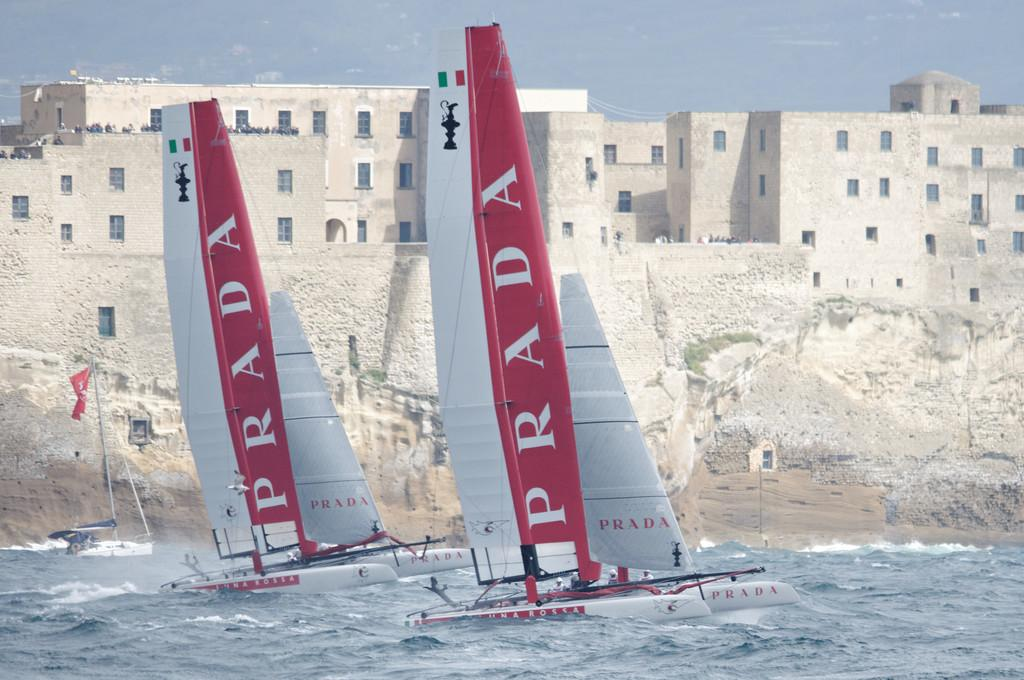What is in the water in the image? There are boats in the water in the image. What can be seen in the background of the image? There are buildings visible in the image. What are the people doing on the buildings? The people are standing on the buildings. How would you describe the sky in the image? The sky is cloudy in the image. What type of tin can be seen in the image? There is no tin present in the image. How many needles are visible in the image? There are no needles visible in the image. 